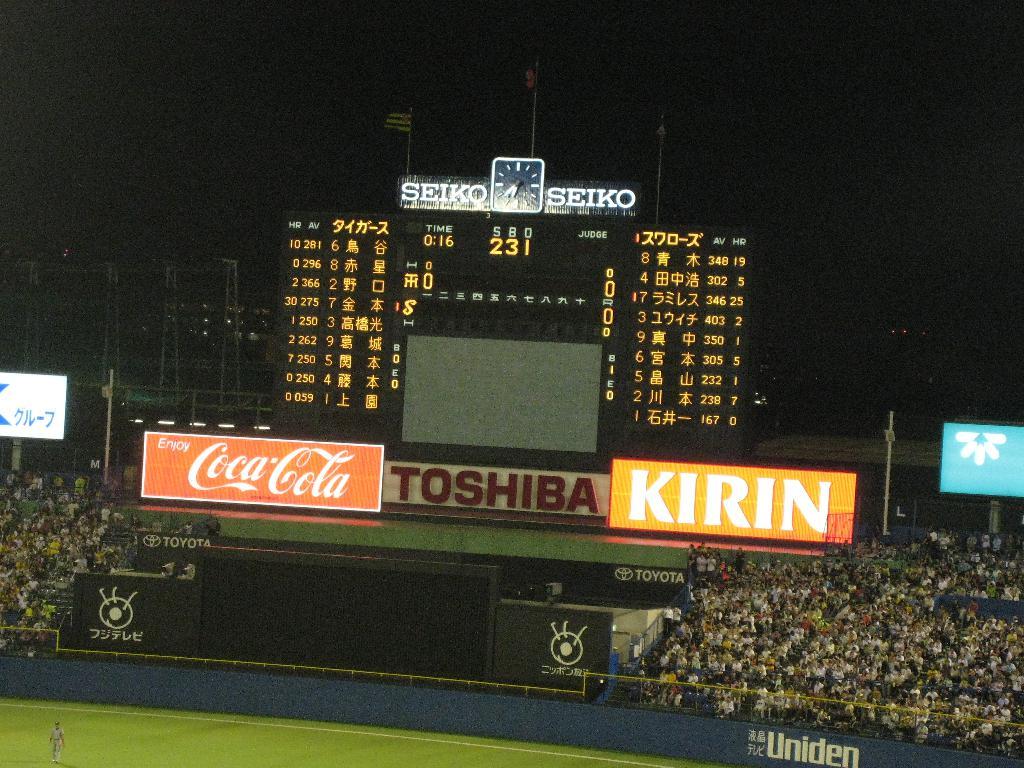What beverage is being advertised?
Offer a very short reply. Coca cola. What car company advertises at this stadium?
Your answer should be compact. Toyota. 